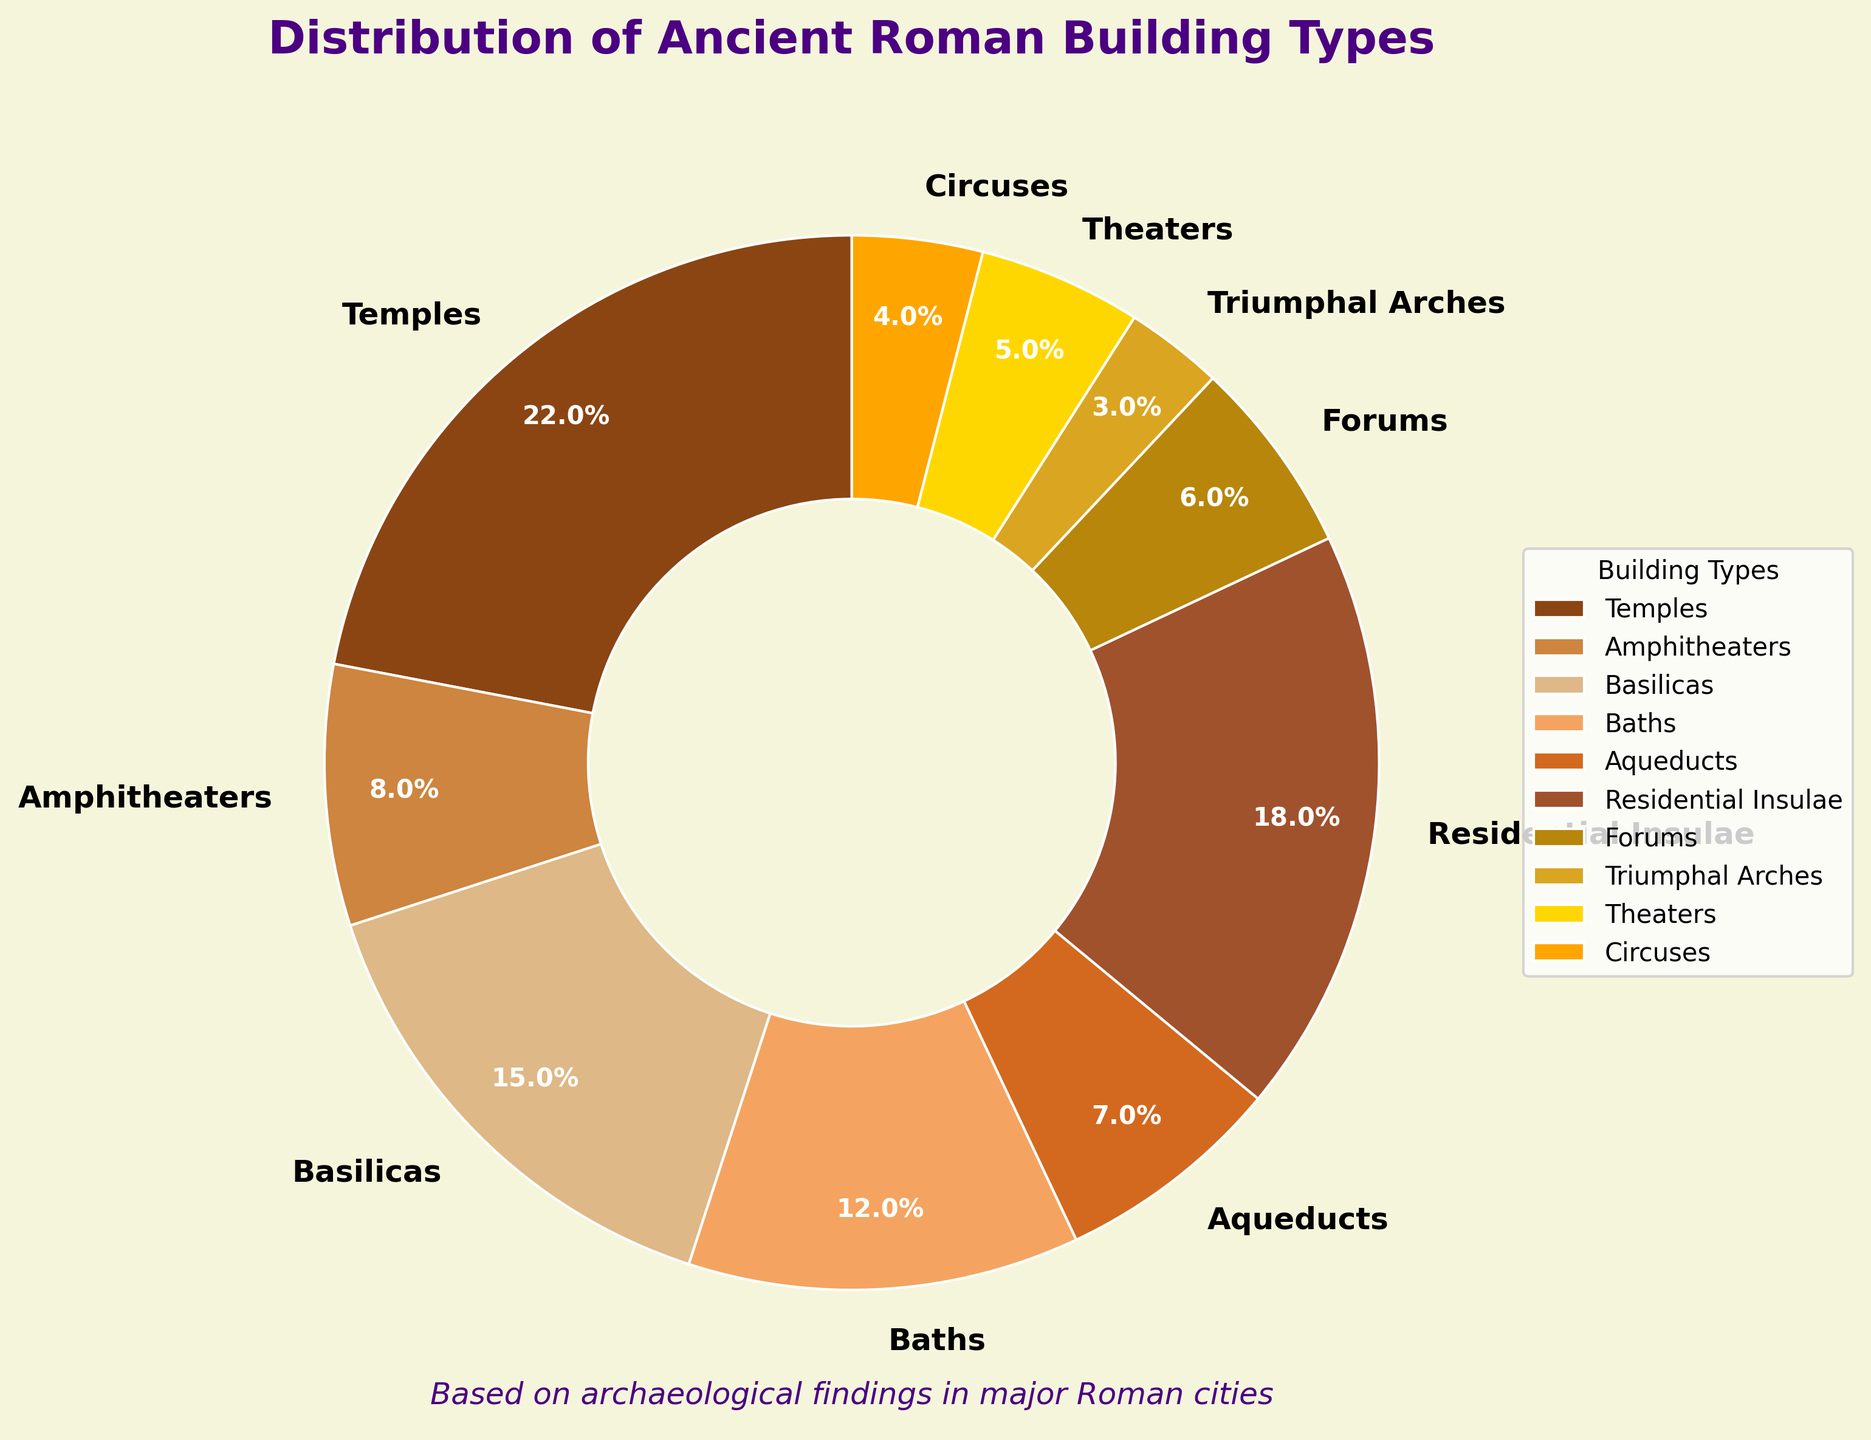Which building type has the highest percentage? From the figure, identify the building type associated with the largest segment. The largest portion of the pie chart represents the building type with the highest percentage.
Answer: Temples What is the combined percentage of Temples and Baths? Identify the percentages of Temples and Baths from the chart and sum them. Temples have 22% and Baths have 12%. Adding these gives 22% + 12% = 34%.
Answer: 34% How much greater is the percentage of Residential Insulae compared to Forums? Look at the percentages for Residential Insulae and Forums. Subtract the percentage of Forums from that of Residential Insulae. Residential Insulae have 18% and Forums have 6%, so the difference is 18% - 6% = 12%.
Answer: 12% Which building type has the smallest segment and what is its percentage? Identify the smallest segment in the pie chart. The smallest segment corresponds to the building type with the smallest percentage.
Answer: Triumphal Arches, 3% How many types of buildings have a percentage greater than 10%? Count the building types that have percentages greater than 10%. From the pie chart, identify and sum the segments that are greater than 10%. Temples (22%), Basilicas (15%), Baths (12%), Residential Insulae (18%) total four types.
Answer: 4 What's the combined percentage of Amphitheaters, Aqueducts, Theaters, and Circuses? Identify the percentages for Amphitheaters, Aqueducts, Theaters, and Circuses from the chart and sum them. Amphitheaters have 8%, Aqueducts have 7%, Theaters have 5%, and Circuses have 4%. Adding these gives 8% + 7% + 5% + 4% = 24%.
Answer: 24% Are there more types of buildings with a percentage less than 10% or more than 10%? Categorize the building types based on their percentages being less than or greater than 10%. Count the number of types in each category. Types less than 10% (Amphitheaters, Aqueducts, Forums, Theaters, Circuses, Triumphal Arches) total six, and types greater than 10% (Temples, Basilicas, Baths, Residential Insulae) total four.
Answer: Less than 10% Which building type representing theaters is visually close to another type, and which type is that? Identify the building segments for theaters and other types that are visually close in size. The segment representing theaters (5%) is visually close to that of Circuses (4%).
Answer: Circuses What is the visual difference between the segment representing Baths and the segment representing Aqueducts? Examine the segments for Baths and Aqueducts. Baths have a larger segment compared to Aqueducts. Baths are 12%, and Aqueducts are 7%. The visual difference is apparent from the size of the segments.
Answer: Baths are larger 